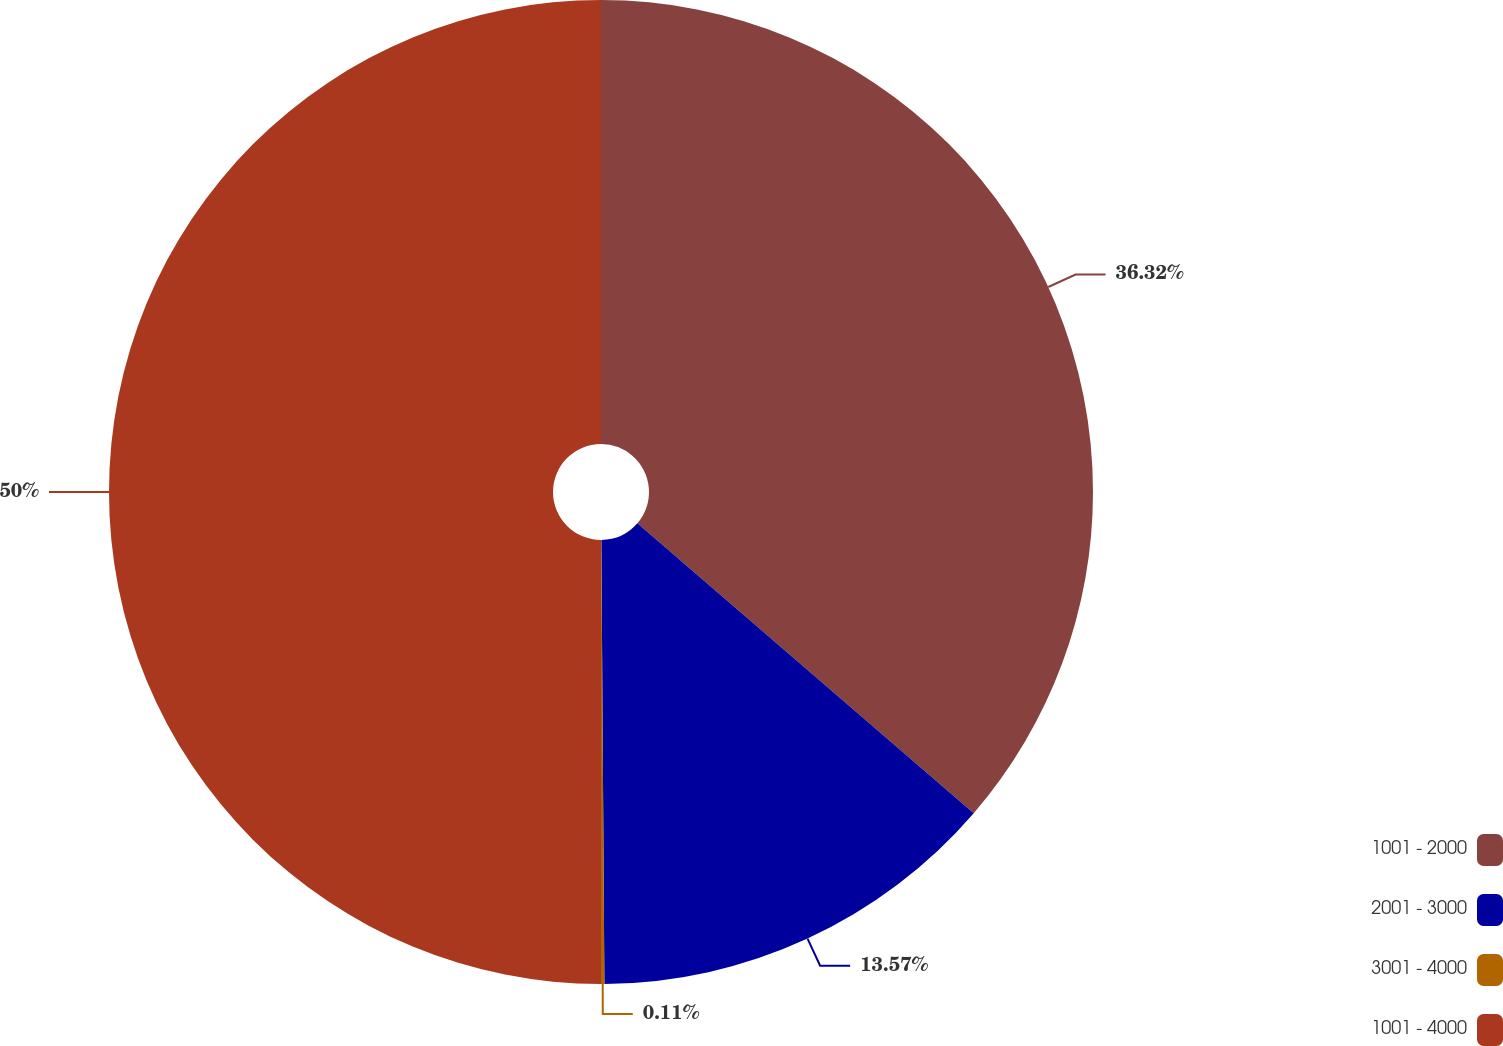Convert chart to OTSL. <chart><loc_0><loc_0><loc_500><loc_500><pie_chart><fcel>1001 - 2000<fcel>2001 - 3000<fcel>3001 - 4000<fcel>1001 - 4000<nl><fcel>36.32%<fcel>13.57%<fcel>0.11%<fcel>50.0%<nl></chart> 